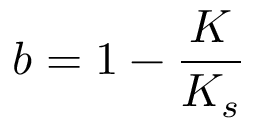Convert formula to latex. <formula><loc_0><loc_0><loc_500><loc_500>b = 1 - \frac { K } { K _ { s } }</formula> 